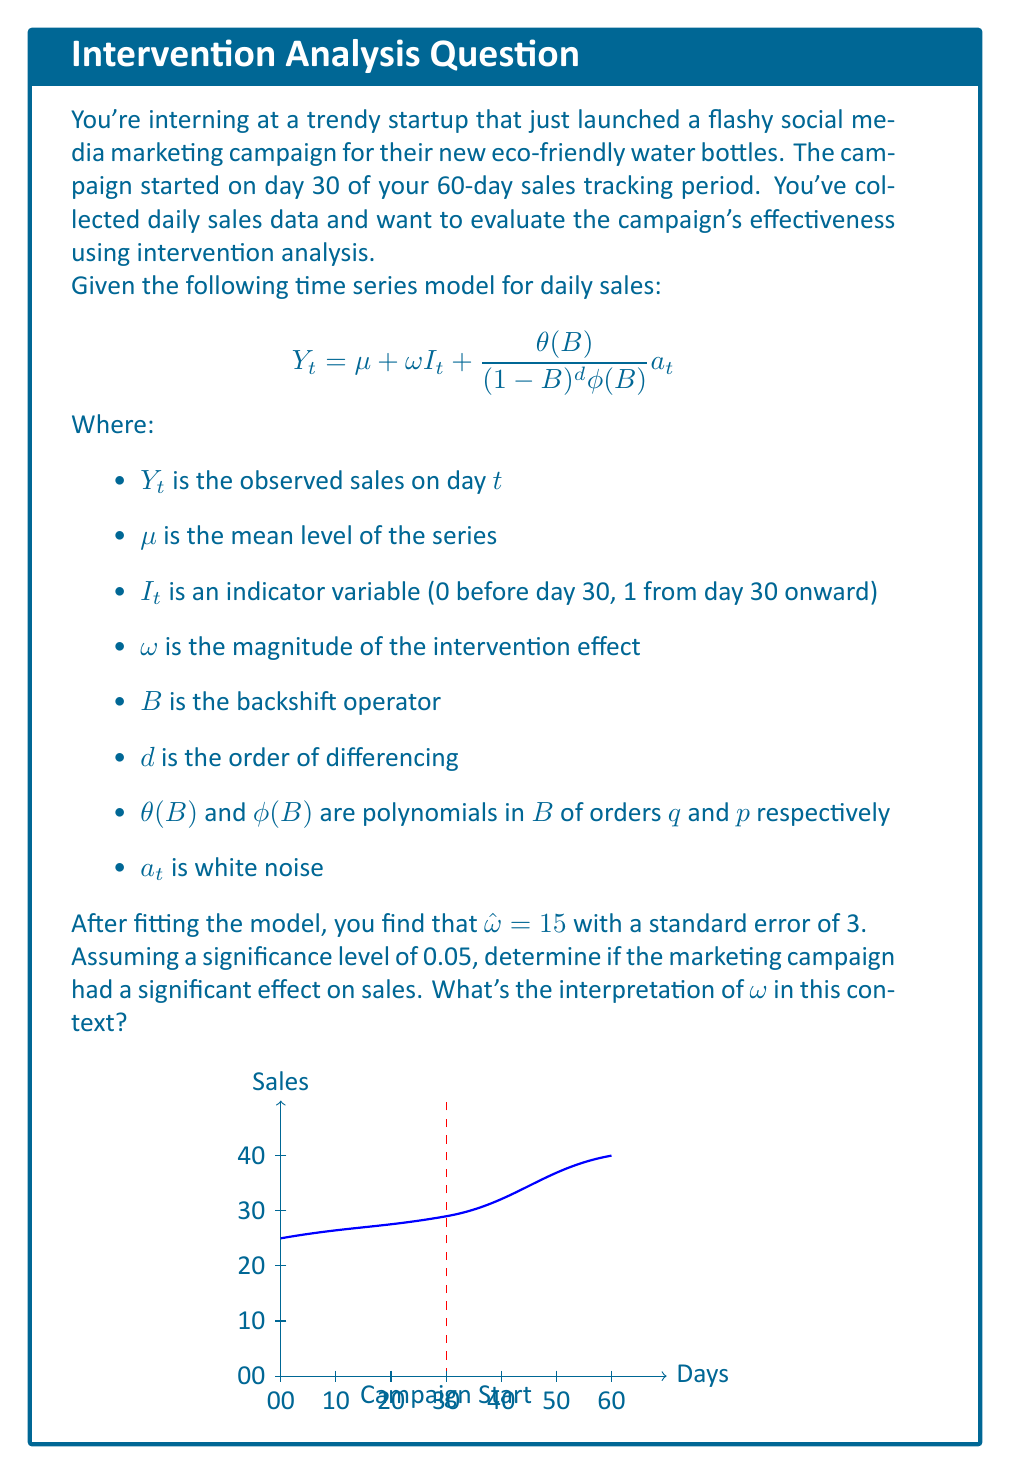Help me with this question. Let's approach this step-by-step:

1) First, we need to understand what $\omega$ represents in this model. It's the magnitude of the intervention effect, which in this case is the estimated increase in daily sales after the marketing campaign began.

2) We're given that $\hat{\omega} = 15$ with a standard error of 3. This means our point estimate suggests that the campaign increased daily sales by 15 units.

3) To determine if this effect is statistically significant, we need to perform a hypothesis test. Our null hypothesis is that the campaign had no effect ($H_0: \omega = 0$), and our alternative hypothesis is that it did have an effect ($H_1: \omega \neq 0$).

4) For a two-tailed test at a 0.05 significance level, we can use the t-statistic. The t-statistic is calculated as:

   $$t = \frac{\hat{\omega} - 0}{SE(\hat{\omega})} = \frac{15}{3} = 5$$

5) The critical t-value for a two-tailed test at 0.05 significance level with large degrees of freedom (assuming we have enough data points) is approximately ±1.96.

6) Since our calculated t-statistic (5) is greater than 1.96, we reject the null hypothesis.

7) This means we have sufficient evidence to conclude that the marketing campaign had a statistically significant effect on sales.

8) The interpretation of $\omega$ in this context is that it represents the average increase in daily sales after the marketing campaign was launched. Our estimate suggests that the campaign increased daily sales by an average of 15 units.
Answer: The campaign had a significant effect, increasing daily sales by an estimated 15 units on average (p < 0.05). 